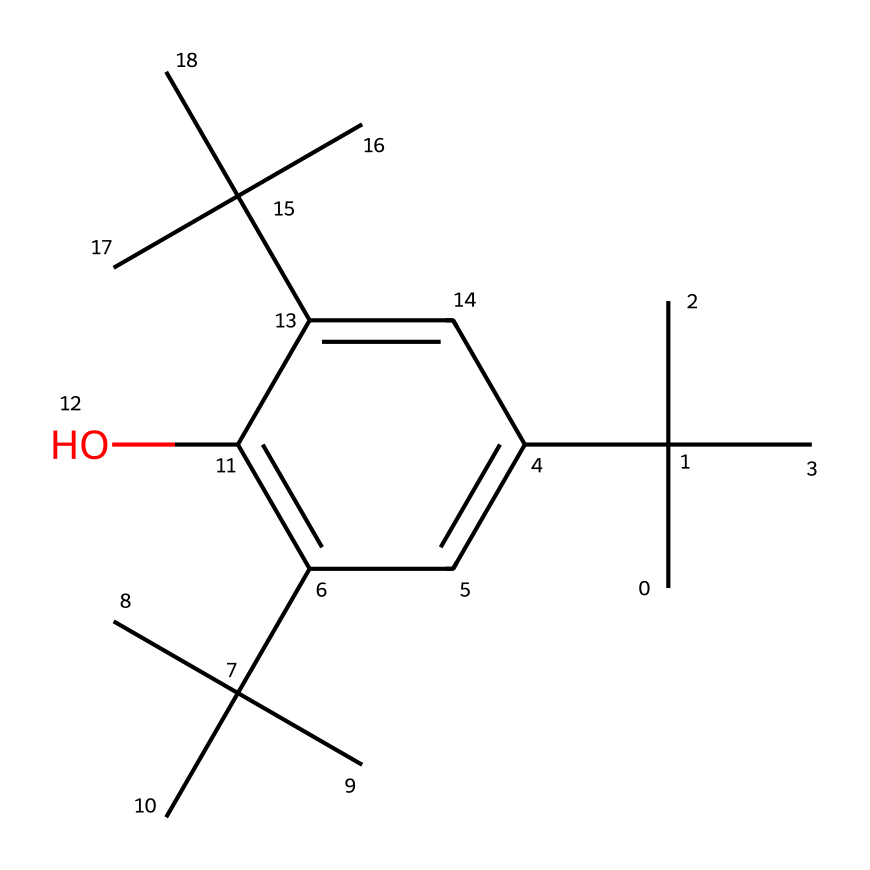What is the name of this chemical compound? The SMILES representation corresponds to a structure that features a branched aliphatic compound with several isopropyl groups and a hydroxyl group. By analyzing the components within the SMILES, it indicates the compound is likely 2,4,4-trimethyl-1,3-cyclopentanediol or a similar derived structure.
Answer: 2,4,4-trimethyl-1,3-cyclopentanediol How many carbon atoms are present in this compound? To find the number of carbon atoms, we can count the occurrences of the letter "C" in the SMILES representation. Each "C" corresponds to a carbon atom. In this structure, there are 18 carbon atoms.
Answer: 18 What is the functional group present in this compound? The presence of the "O" in the SMILES structure represents a hydroxyl group (-OH), which is a functional group indicative of alcohols. Thus, the functional group is a hydroxyl group.
Answer: hydroxyl group How many isopropyl groups are present in the structure? Isopropyl groups are characterized by the structure "C(C)(C)" and can be identified by examining the arrangement in the SMILES representation. There are four occurrences of isopropyl groups in the structure.
Answer: 4 What type of compound is indicated by the aliphatic structure? The presence of long carbon chains and branching without any cycles or unsaturation indicates that this is an aliphatic compound, specifically a branched alkane due to the saturated nature of the structure.
Answer: branched alkane Does this compound contain any double bonds? The SMILES representation only contains single bonds among the carbon atoms, evidenced by the absence of "double bond" markers such as "=". Therefore, there are no double bonds in this compound.
Answer: No 